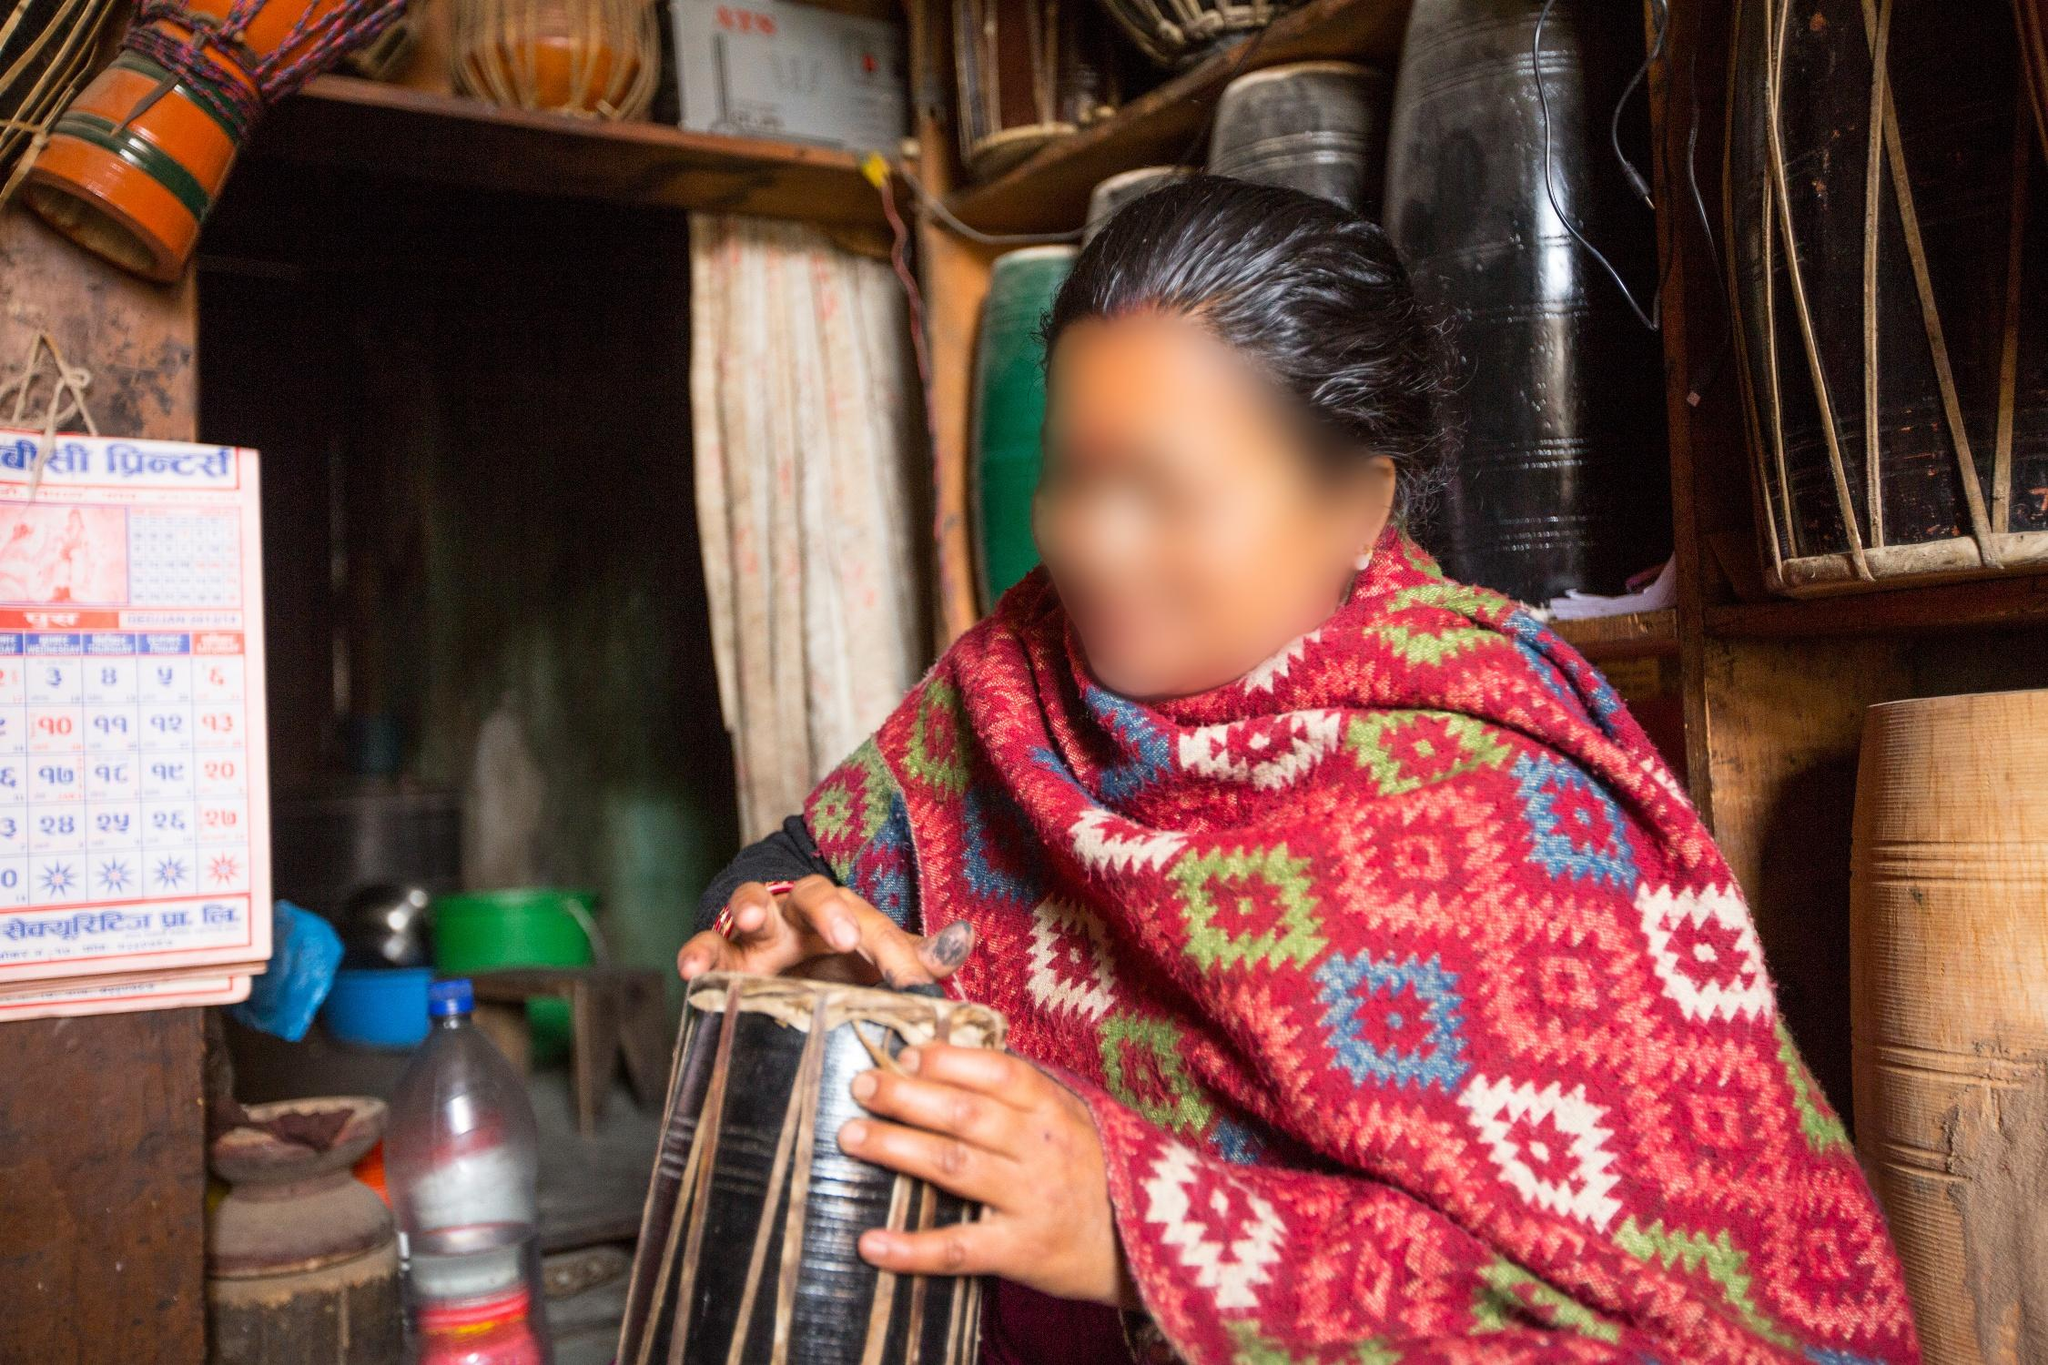Can you identify the musical instrument in the picture and describe its cultural significance? The musical instrument in the picture is a madal, a traditional Nepali percussion instrument. The madal is an integral part of Nepali folk music and is commonly used in various cultural and social functions, including festivals, weddings, and religious ceremonies. Its rhythmic beats provide a lively tempo to dances and songs, making it a treasured element of Nepali musical heritage. Tell me more about the person in the picture. What can you infer from their attire and setting? The person in the picture is clad in a vibrant shawl with bold patterns, suggesting a connection to traditional Nepali attire, which is often colorful and elaborately designed. They appear to be in a small, rustic shop filled with various goods, indicating a setting in a local marketplace or a roadside store. The blurred face indicates an effort to maintain their privacy. The person's immersion in playing the madal also signifies the importance of music in their life and possibly hints at their role as a musician or someone who enjoys cultural expressions through music. What other items can you see in the shop, and what do they tell us about the local culture and lifestyle? In the shop, there are several items visible on the shelves behind the person, including baskets, pots, and containers. These items are indicative of everyday utility in a traditional Nepali household. The presence of a calendar written in Nepali script reinforces the cultural context and adherence to local practices and traditions. The shop's assortment of practical goods suggests a lifestyle that values handcrafted items and domestic functionality, reflecting a community-oriented, practical approach to daily living. If this shop could tell a story, what do you think it would be? This shop could tell a story of a vibrant community where tradition and modernity blend seamlessly. It might recount the daily lives of locals who visit to purchase necessities and perhaps stay for a moment to enjoy the soothing beats of the madal. It could narrate tales of festive nights filled with music and dance, where the madal played a central role. The shop might also share quieter stories of continuity and change, as it has adapted over the years while preserving its cultural essence. 